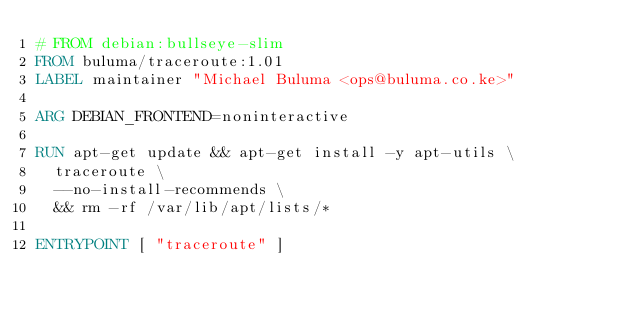<code> <loc_0><loc_0><loc_500><loc_500><_Dockerfile_># FROM debian:bullseye-slim
FROM buluma/traceroute:1.01
LABEL maintainer "Michael Buluma <ops@buluma.co.ke>"

ARG DEBIAN_FRONTEND=noninteractive

RUN apt-get update && apt-get install -y apt-utils \
	traceroute \
	--no-install-recommends \
	&& rm -rf /var/lib/apt/lists/*

ENTRYPOINT [ "traceroute" ]
</code> 